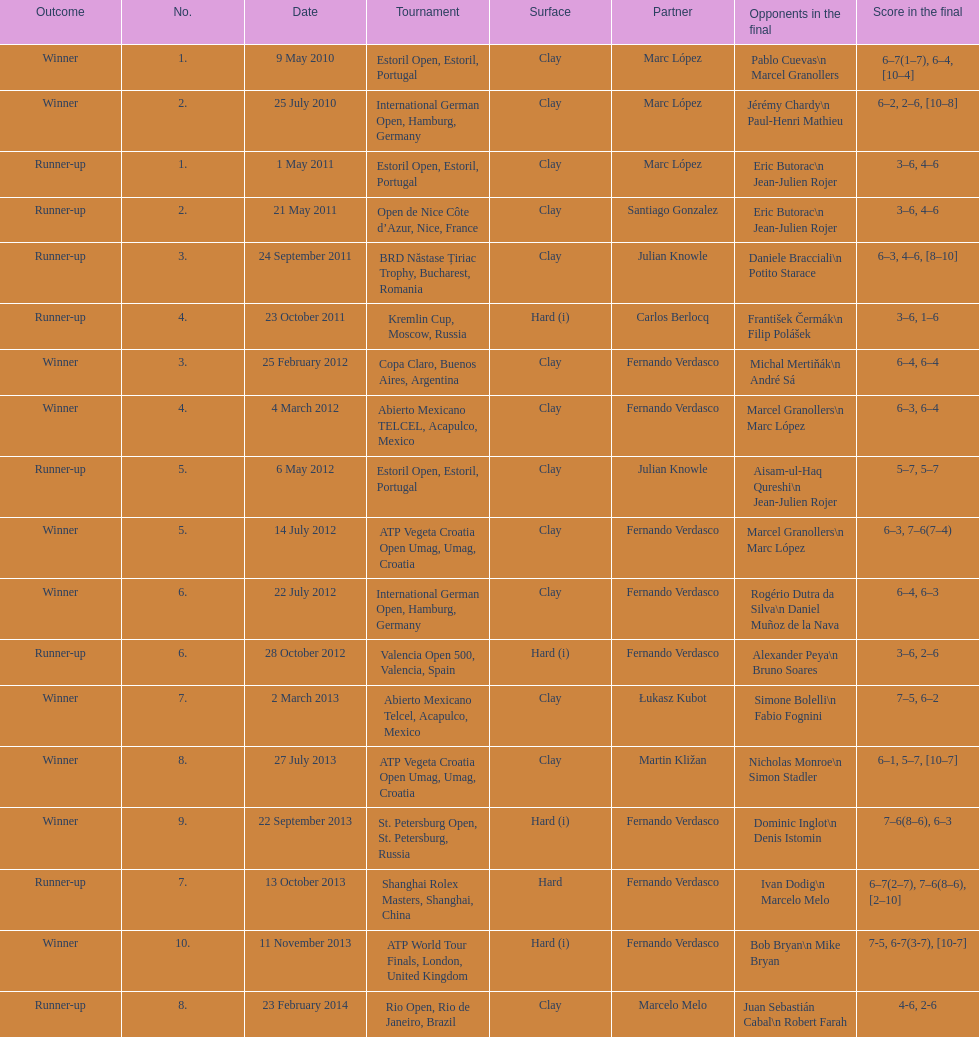How many tournaments has this player won in his career so far? 10. 